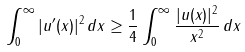<formula> <loc_0><loc_0><loc_500><loc_500>\int _ { 0 } ^ { \infty } | u ^ { \prime } ( x ) | ^ { 2 } \, d x \geq \frac { 1 } { 4 } \int _ { 0 } ^ { \infty } \frac { | u ( x ) | ^ { 2 } } { x ^ { 2 } } \, d x</formula> 